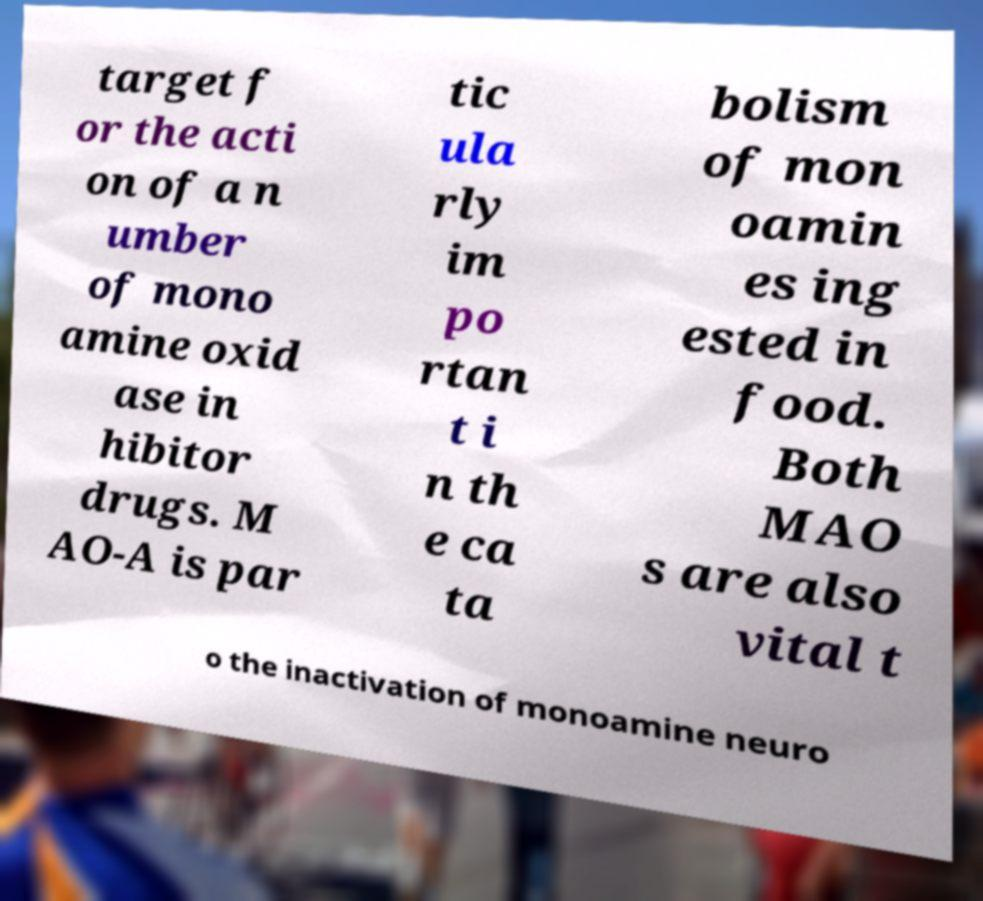For documentation purposes, I need the text within this image transcribed. Could you provide that? target f or the acti on of a n umber of mono amine oxid ase in hibitor drugs. M AO-A is par tic ula rly im po rtan t i n th e ca ta bolism of mon oamin es ing ested in food. Both MAO s are also vital t o the inactivation of monoamine neuro 